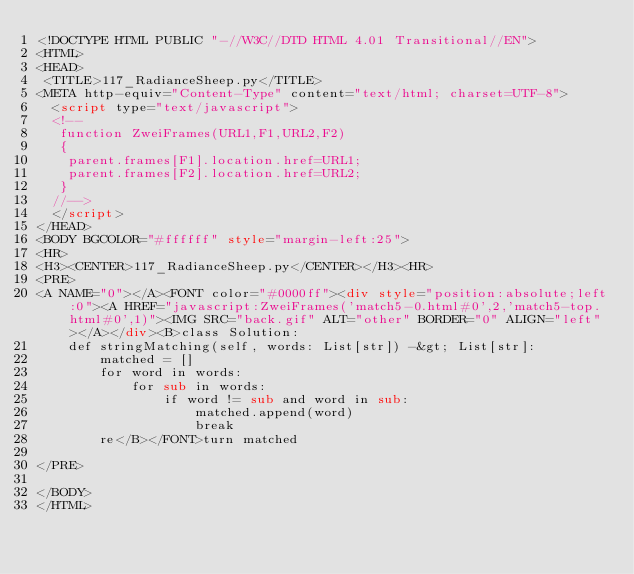Convert code to text. <code><loc_0><loc_0><loc_500><loc_500><_HTML_><!DOCTYPE HTML PUBLIC "-//W3C//DTD HTML 4.01 Transitional//EN">
<HTML>
<HEAD>
 <TITLE>117_RadianceSheep.py</TITLE>
<META http-equiv="Content-Type" content="text/html; charset=UTF-8">
  <script type="text/javascript">
  <!--
   function ZweiFrames(URL1,F1,URL2,F2)
   {
    parent.frames[F1].location.href=URL1;
    parent.frames[F2].location.href=URL2;
   }
  //-->
  </script>
</HEAD>
<BODY BGCOLOR="#ffffff" style="margin-left:25">
<HR>
<H3><CENTER>117_RadianceSheep.py</CENTER></H3><HR>
<PRE>
<A NAME="0"></A><FONT color="#0000ff"><div style="position:absolute;left:0"><A HREF="javascript:ZweiFrames('match5-0.html#0',2,'match5-top.html#0',1)"><IMG SRC="back.gif" ALT="other" BORDER="0" ALIGN="left"></A></div><B>class Solution:
    def stringMatching(self, words: List[str]) -&gt; List[str]:
        matched = []
        for word in words:
            for sub in words:
                if word != sub and word in sub:
                    matched.append(word)
                    break
        re</B></FONT>turn matched
        
</PRE>

</BODY>
</HTML>
</code> 